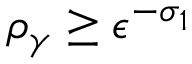Convert formula to latex. <formula><loc_0><loc_0><loc_500><loc_500>\rho _ { \gamma } \geq \epsilon ^ { - \sigma _ { 1 } }</formula> 